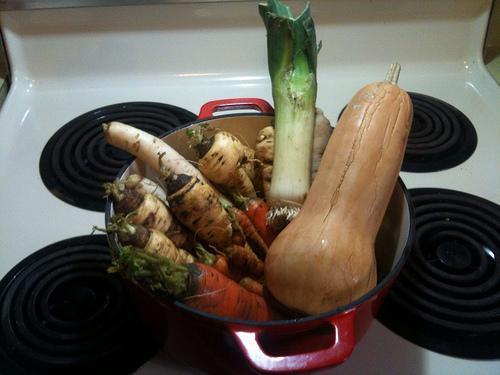How many pots are there?
Give a very brief answer. 1. 